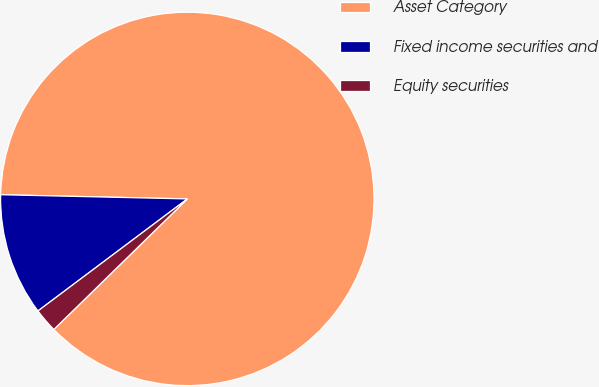Convert chart to OTSL. <chart><loc_0><loc_0><loc_500><loc_500><pie_chart><fcel>Asset Category<fcel>Fixed income securities and<fcel>Equity securities<nl><fcel>87.32%<fcel>10.6%<fcel>2.08%<nl></chart> 